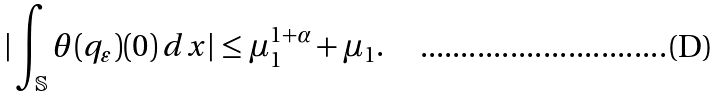Convert formula to latex. <formula><loc_0><loc_0><loc_500><loc_500>| \int _ { \mathbb { S } } \theta ( q _ { \varepsilon } ) ( 0 ) \, d x | \leq \mu _ { 1 } ^ { 1 + \alpha } + \mu _ { 1 } .</formula> 